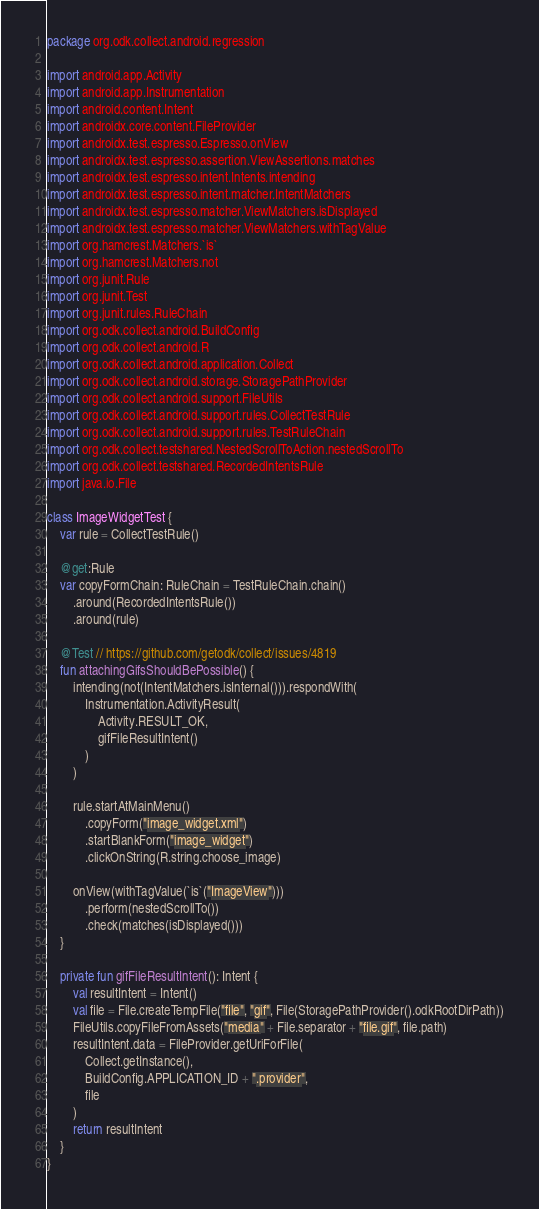<code> <loc_0><loc_0><loc_500><loc_500><_Kotlin_>package org.odk.collect.android.regression

import android.app.Activity
import android.app.Instrumentation
import android.content.Intent
import androidx.core.content.FileProvider
import androidx.test.espresso.Espresso.onView
import androidx.test.espresso.assertion.ViewAssertions.matches
import androidx.test.espresso.intent.Intents.intending
import androidx.test.espresso.intent.matcher.IntentMatchers
import androidx.test.espresso.matcher.ViewMatchers.isDisplayed
import androidx.test.espresso.matcher.ViewMatchers.withTagValue
import org.hamcrest.Matchers.`is`
import org.hamcrest.Matchers.not
import org.junit.Rule
import org.junit.Test
import org.junit.rules.RuleChain
import org.odk.collect.android.BuildConfig
import org.odk.collect.android.R
import org.odk.collect.android.application.Collect
import org.odk.collect.android.storage.StoragePathProvider
import org.odk.collect.android.support.FileUtils
import org.odk.collect.android.support.rules.CollectTestRule
import org.odk.collect.android.support.rules.TestRuleChain
import org.odk.collect.testshared.NestedScrollToAction.nestedScrollTo
import org.odk.collect.testshared.RecordedIntentsRule
import java.io.File

class ImageWidgetTest {
    var rule = CollectTestRule()

    @get:Rule
    var copyFormChain: RuleChain = TestRuleChain.chain()
        .around(RecordedIntentsRule())
        .around(rule)

    @Test // https://github.com/getodk/collect/issues/4819
    fun attachingGifsShouldBePossible() {
        intending(not(IntentMatchers.isInternal())).respondWith(
            Instrumentation.ActivityResult(
                Activity.RESULT_OK,
                gifFileResultIntent()
            )
        )

        rule.startAtMainMenu()
            .copyForm("image_widget.xml")
            .startBlankForm("image_widget")
            .clickOnString(R.string.choose_image)

        onView(withTagValue(`is`("ImageView")))
            .perform(nestedScrollTo())
            .check(matches(isDisplayed()))
    }

    private fun gifFileResultIntent(): Intent {
        val resultIntent = Intent()
        val file = File.createTempFile("file", "gif", File(StoragePathProvider().odkRootDirPath))
        FileUtils.copyFileFromAssets("media" + File.separator + "file.gif", file.path)
        resultIntent.data = FileProvider.getUriForFile(
            Collect.getInstance(),
            BuildConfig.APPLICATION_ID + ".provider",
            file
        )
        return resultIntent
    }
}
</code> 